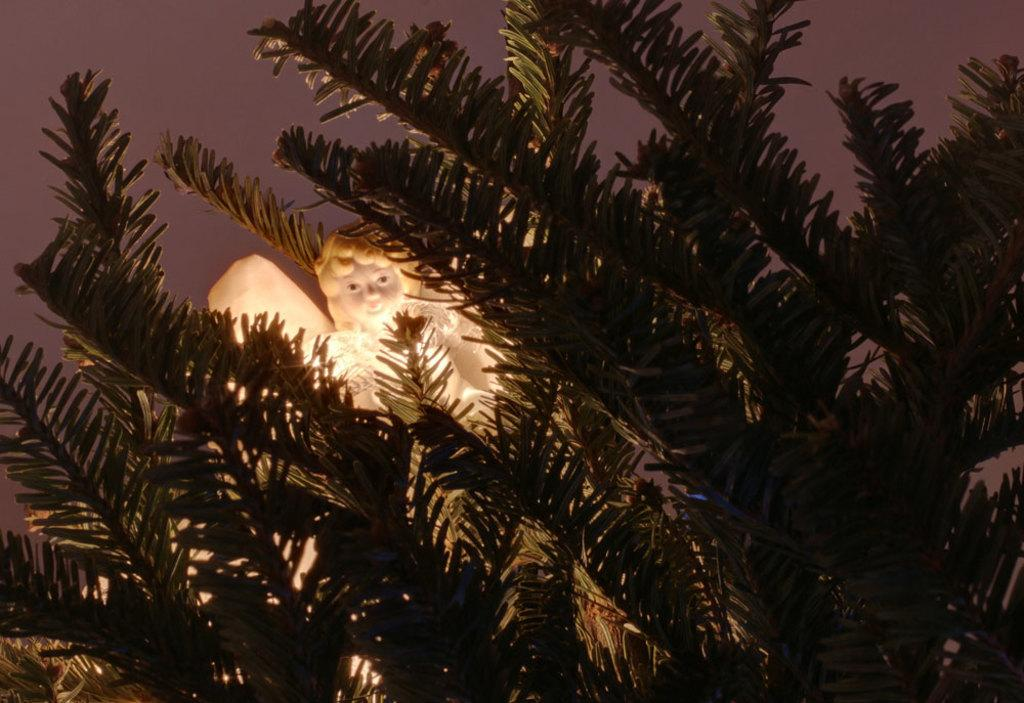What is the main subject of the image? There is a statue of a girl with wings in the image. Where is the statue located? The statue is located between trees. What can be seen in the background of the image? The sky is visible in the background of the image. What type of knife is being used to peel the potato in the image? There is no knife or potato present in the image; it features a statue of a girl with wings located between trees. 